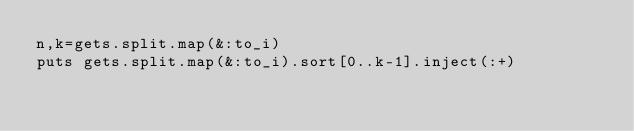Convert code to text. <code><loc_0><loc_0><loc_500><loc_500><_Ruby_>n,k=gets.split.map(&:to_i)
puts gets.split.map(&:to_i).sort[0..k-1].inject(:+)
</code> 